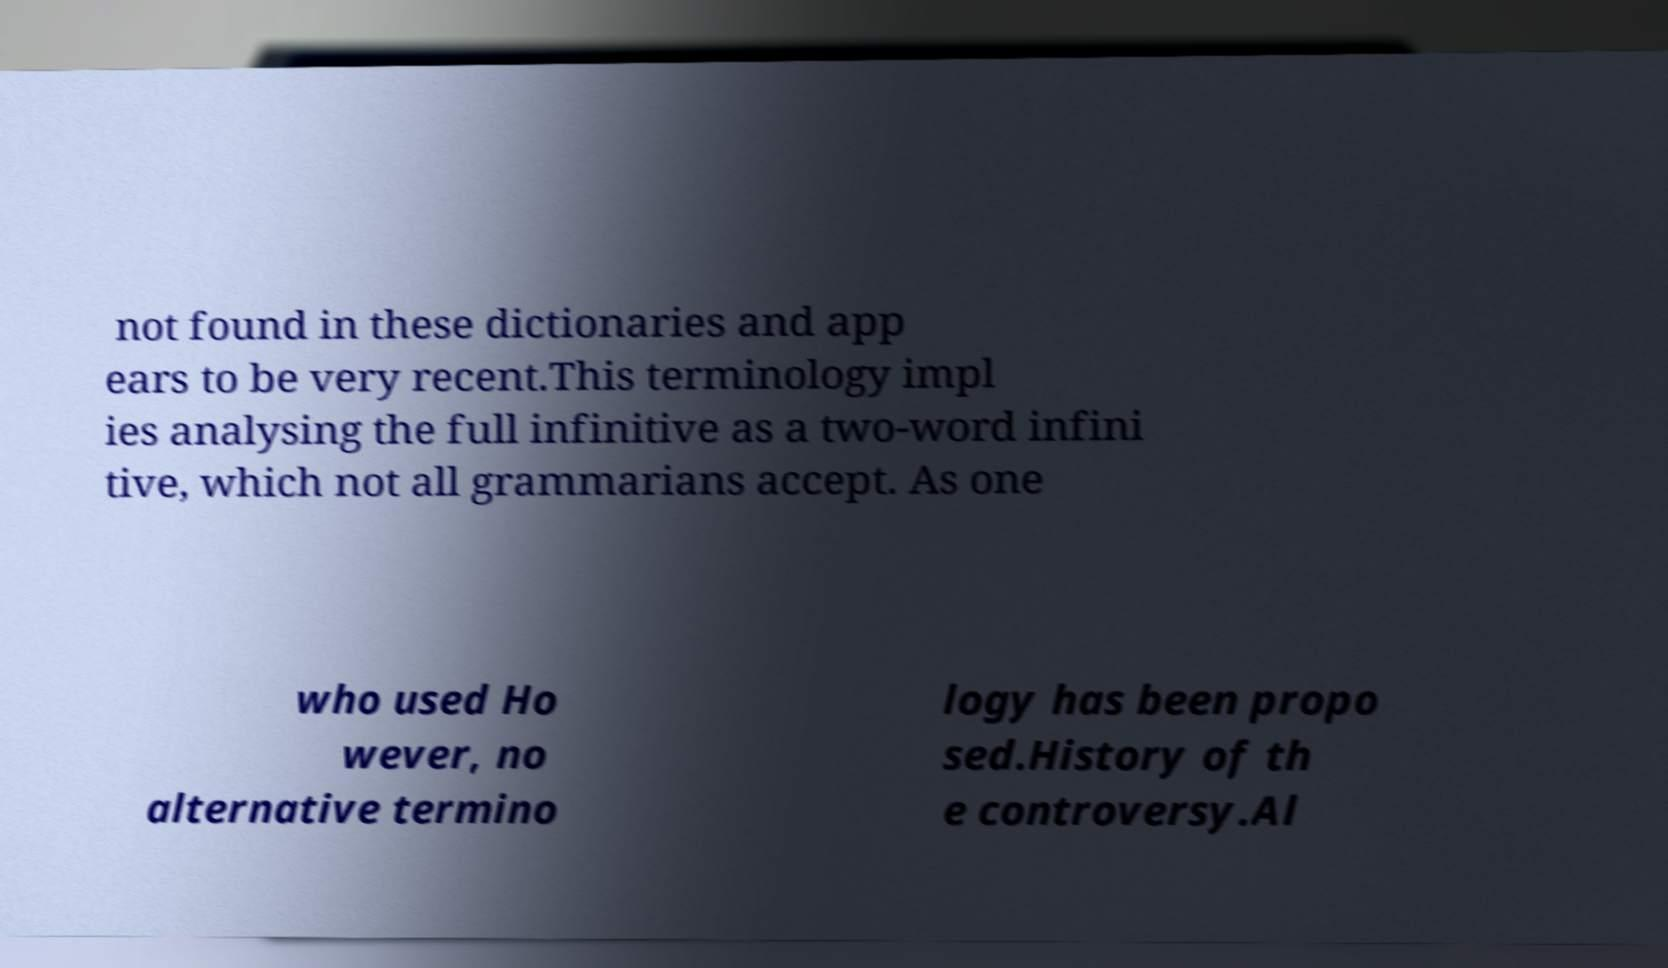Please identify and transcribe the text found in this image. not found in these dictionaries and app ears to be very recent.This terminology impl ies analysing the full infinitive as a two-word infini tive, which not all grammarians accept. As one who used Ho wever, no alternative termino logy has been propo sed.History of th e controversy.Al 